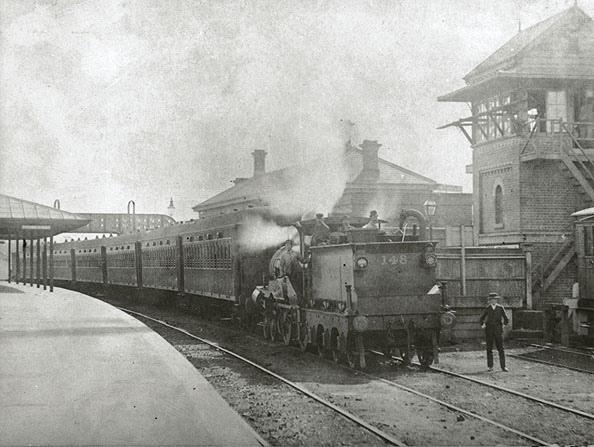Was this picture taken within the last 10 years?
Be succinct. No. Could this be powered by steam?
Keep it brief. Yes. Is this a color picture?
Write a very short answer. No. 